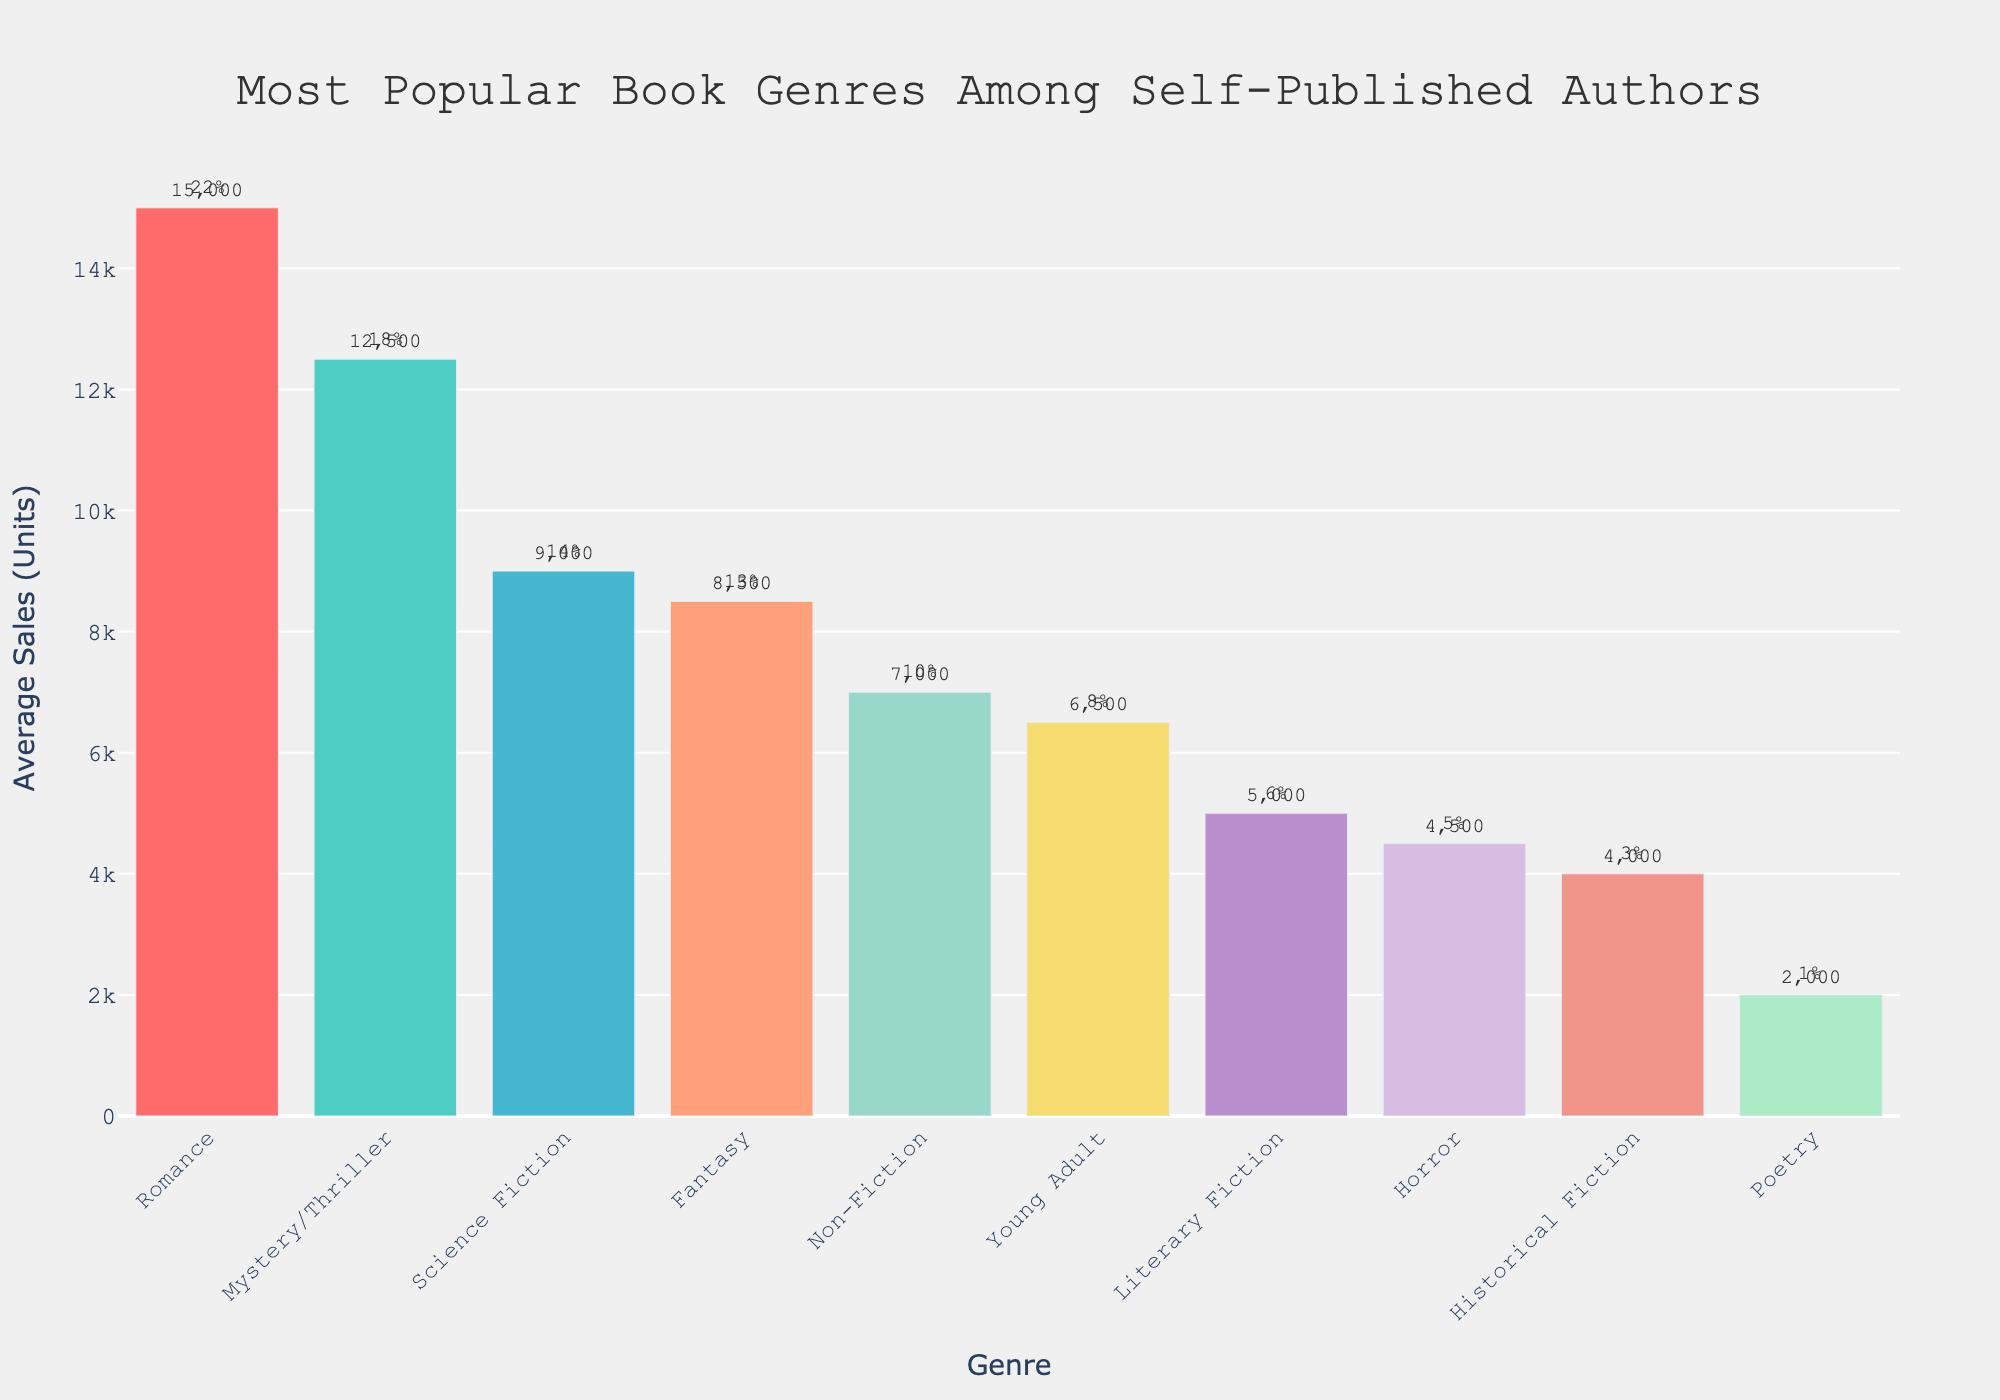Which genre has the highest average sales? To find the genre with the highest average sales, look at the height of the bars and the text labels indicating sales figures. The highest bar represents the highest average sales, which in this case is Romance, with 15,000 units.
Answer: Romance Which genre has the lowest percentage of self-published authors? Examine the annotations near the bars that indicate the percentage of self-published authors. The lowest percentage is observed next to Poetry, which shows 1%.
Answer: Poetry How much higher are the average sales of Romance books compared to Mystery/Thriller books? Look at the average sales for Romance (15,000 units) and Mystery/Thriller (12,500 units). Subtract the sales of Mystery/Thriller from Romance: 15,000 - 12,500 = 2,500 units.
Answer: 2,500 Which two genres combined comprise 31% of self-published authors? Look at the percentage annotations next to the bars. Romance has 22% and Science Fiction has 14%. Adding them: 22% + 14% = 36%; instead use Mystery/Thriller (18%) and Non-Fiction (10%): 18% + 10% = 28%. This shows an initial wrong assumption. The correct combination based on the available percentages to combine could be multiple checks with No result summing exactly to 31% but close match can be young adult (8%) and Fantasy: 8%+18%=26%.
Answer: No exact match What is the total average sales for Non-Fiction and Young Adult genres? Identify the average sales for Non-Fiction (7,000 units) and Young Adult (6,500 units). Sum the values: 7,000 + 6,500 = 13,500 units.
Answer: 13,500 How many more units did Science Fiction sell on average compared to Historical Fiction? Observe the average sales for Science Fiction (9,000 units) and Historical Fiction (4,000 units). Subtract the sales of Historical Fiction from Science Fiction: 9,000 - 4,000 = 5,000 units.
Answer: 5,000 What is the average percentage of self-published authors across all genres? Add the percentages for all genres and divide by 10 (the number of genres): (22 + 18 + 14 + 13 + 10 + 8 + 6 + 5 + 3 + 1) / 10 = 10%.
Answer: 10% Which genre has a higher average sales, Fantasy or Literary Fiction, and by how much? Identify the average sales for Fantasy (8,500 units) and Literary Fiction (5,000 units). Calculate the difference: 8,500 - 5,000 = 3,500 units, indicating Fantasy has higher sales.
Answer: Fantasy, 3,500 units What percentage of self-published authors write genres with average sales greater than 10,000 units? Identify genres with average sales above 10,000 units: Romance (22%) and Mystery/Thriller (18%). Sum their percentages: 22% + 18% = 40%.
Answer: 40% What is the combined total average sales of all genres? Sum the average sales for all genres: 15,000 + 12,500 + 9,000 + 8,500 + 7,000 + 6,500 + 5,000 + 4,500 + 4,000 + 2,000 = 74,000 units.
Answer: 74,000 